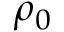Convert formula to latex. <formula><loc_0><loc_0><loc_500><loc_500>\rho _ { 0 }</formula> 